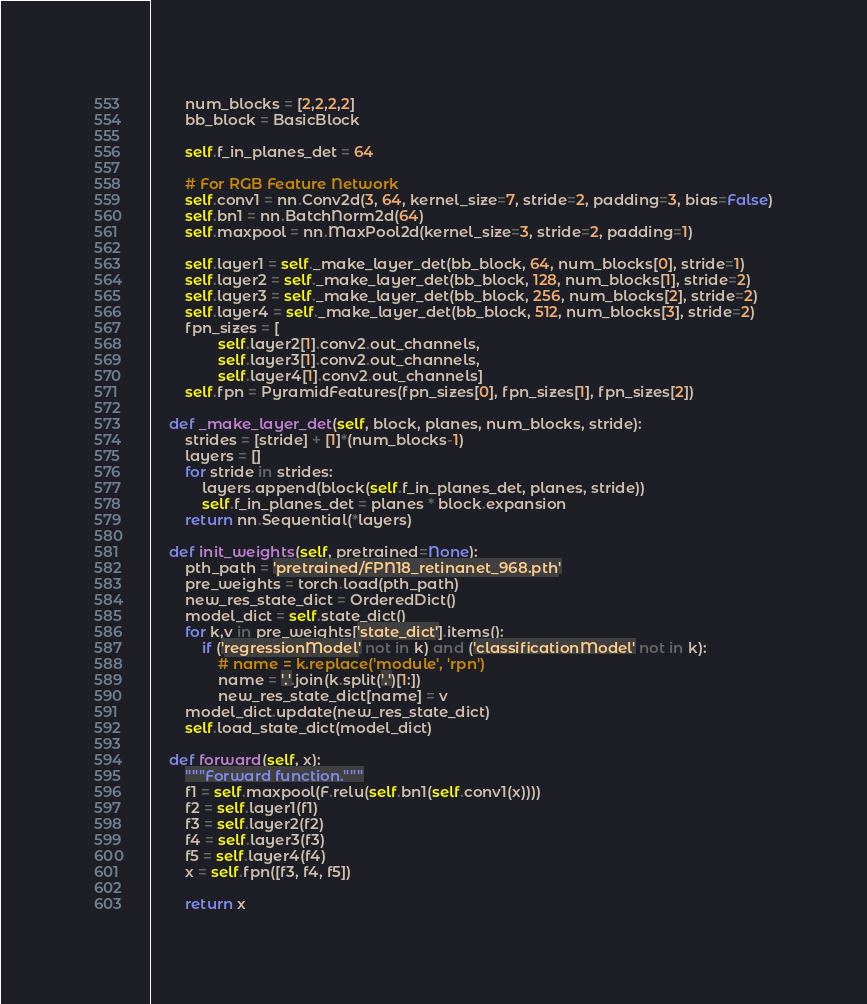<code> <loc_0><loc_0><loc_500><loc_500><_Python_>        num_blocks = [2,2,2,2]
        bb_block = BasicBlock

        self.f_in_planes_det = 64

        # For RGB Feature Network
        self.conv1 = nn.Conv2d(3, 64, kernel_size=7, stride=2, padding=3, bias=False)
        self.bn1 = nn.BatchNorm2d(64)
        self.maxpool = nn.MaxPool2d(kernel_size=3, stride=2, padding=1)

        self.layer1 = self._make_layer_det(bb_block, 64, num_blocks[0], stride=1)
        self.layer2 = self._make_layer_det(bb_block, 128, num_blocks[1], stride=2)
        self.layer3 = self._make_layer_det(bb_block, 256, num_blocks[2], stride=2)
        self.layer4 = self._make_layer_det(bb_block, 512, num_blocks[3], stride=2)
        fpn_sizes = [
                self.layer2[1].conv2.out_channels,
                self.layer3[1].conv2.out_channels,
                self.layer4[1].conv2.out_channels]
        self.fpn = PyramidFeatures(fpn_sizes[0], fpn_sizes[1], fpn_sizes[2])

    def _make_layer_det(self, block, planes, num_blocks, stride):
        strides = [stride] + [1]*(num_blocks-1)
        layers = []
        for stride in strides:
            layers.append(block(self.f_in_planes_det, planes, stride))
            self.f_in_planes_det = planes * block.expansion
        return nn.Sequential(*layers)

    def init_weights(self, pretrained=None):
        pth_path = 'pretrained/FPN18_retinanet_968.pth'
        pre_weights = torch.load(pth_path)
        new_res_state_dict = OrderedDict()
        model_dict = self.state_dict()
        for k,v in pre_weights['state_dict'].items():
            if ('regressionModel' not in k) and ('classificationModel' not in k):
                # name = k.replace('module', 'rpn')
                name = '.'.join(k.split('.')[1:])
                new_res_state_dict[name] = v
        model_dict.update(new_res_state_dict) 
        self.load_state_dict(model_dict)

    def forward(self, x):
        """Forward function."""
        f1 = self.maxpool(F.relu(self.bn1(self.conv1(x))))
        f2 = self.layer1(f1)
        f3 = self.layer2(f2)
        f4 = self.layer3(f3)
        f5 = self.layer4(f4)
        x = self.fpn([f3, f4, f5])

        return x
</code> 